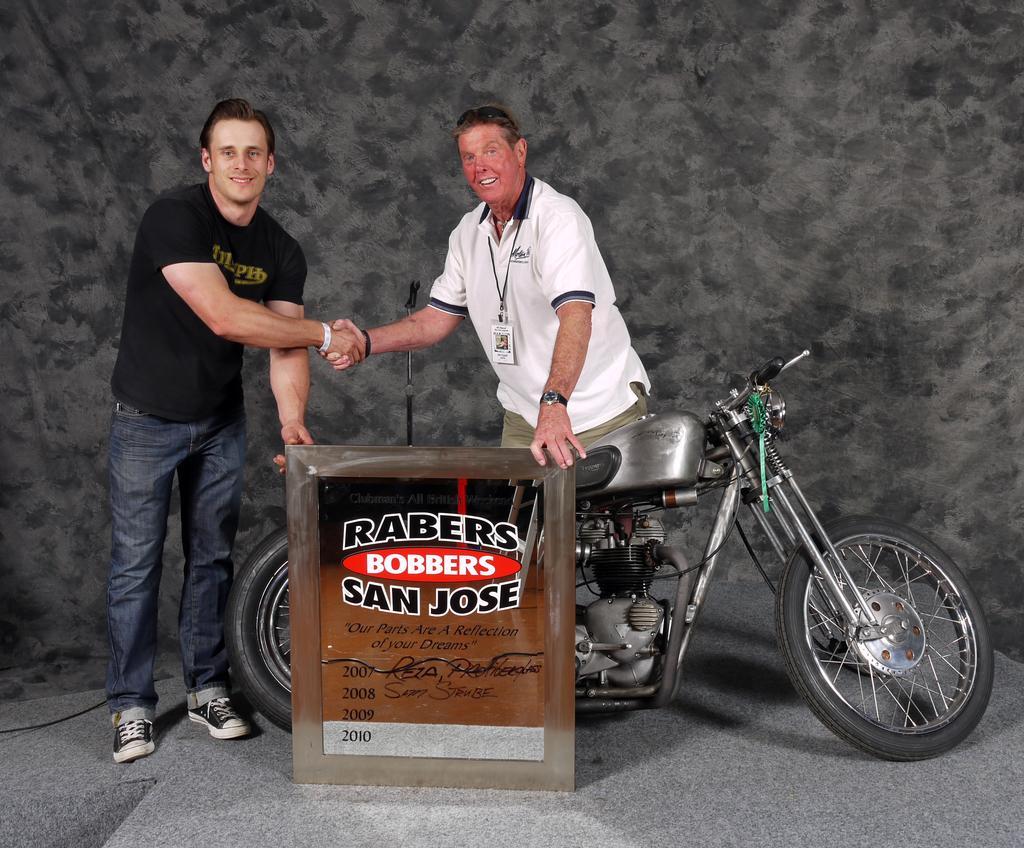Could you give a brief overview of what you see in this image? In this image there are two persons shaking hands, one of the person holding a board, in between the board and person there is a bike, in the background there is a wall. 